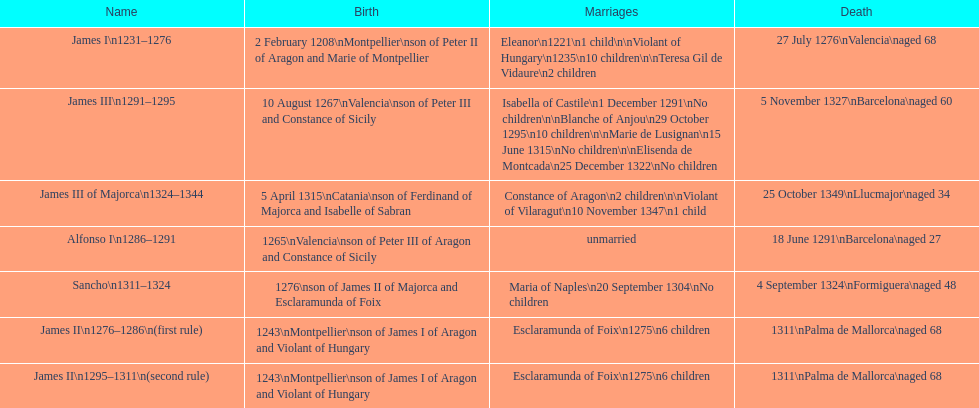What was the length of james ii's rule, taking into account his second reign? 26 years. 